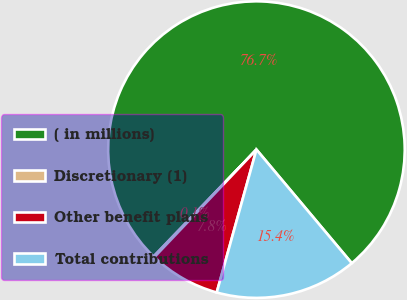<chart> <loc_0><loc_0><loc_500><loc_500><pie_chart><fcel>( in millions)<fcel>Discretionary (1)<fcel>Other benefit plans<fcel>Total contributions<nl><fcel>76.69%<fcel>0.11%<fcel>7.77%<fcel>15.43%<nl></chart> 